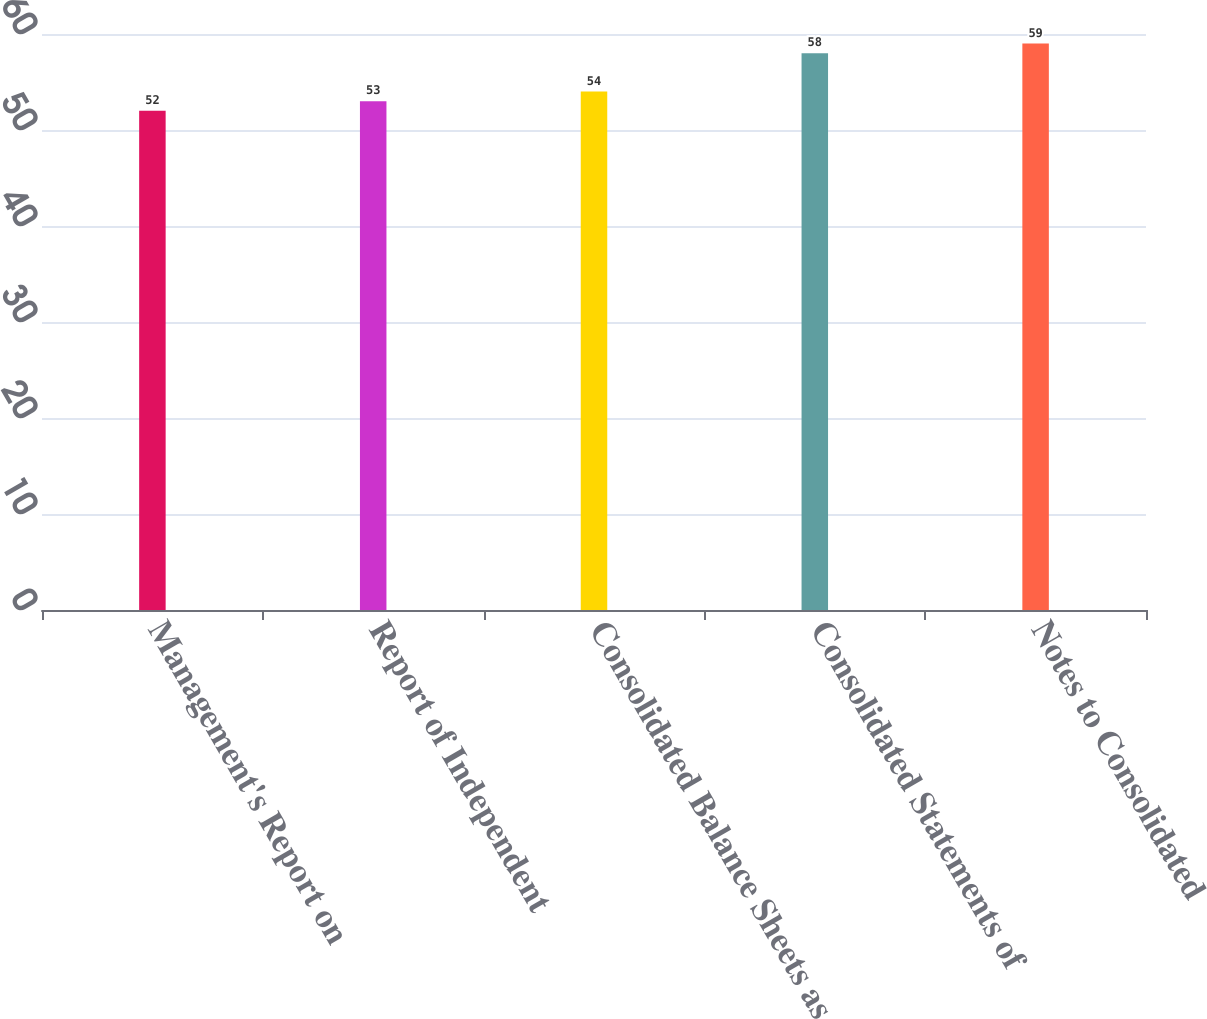Convert chart to OTSL. <chart><loc_0><loc_0><loc_500><loc_500><bar_chart><fcel>Management's Report on<fcel>Report of Independent<fcel>Consolidated Balance Sheets as<fcel>Consolidated Statements of<fcel>Notes to Consolidated<nl><fcel>52<fcel>53<fcel>54<fcel>58<fcel>59<nl></chart> 